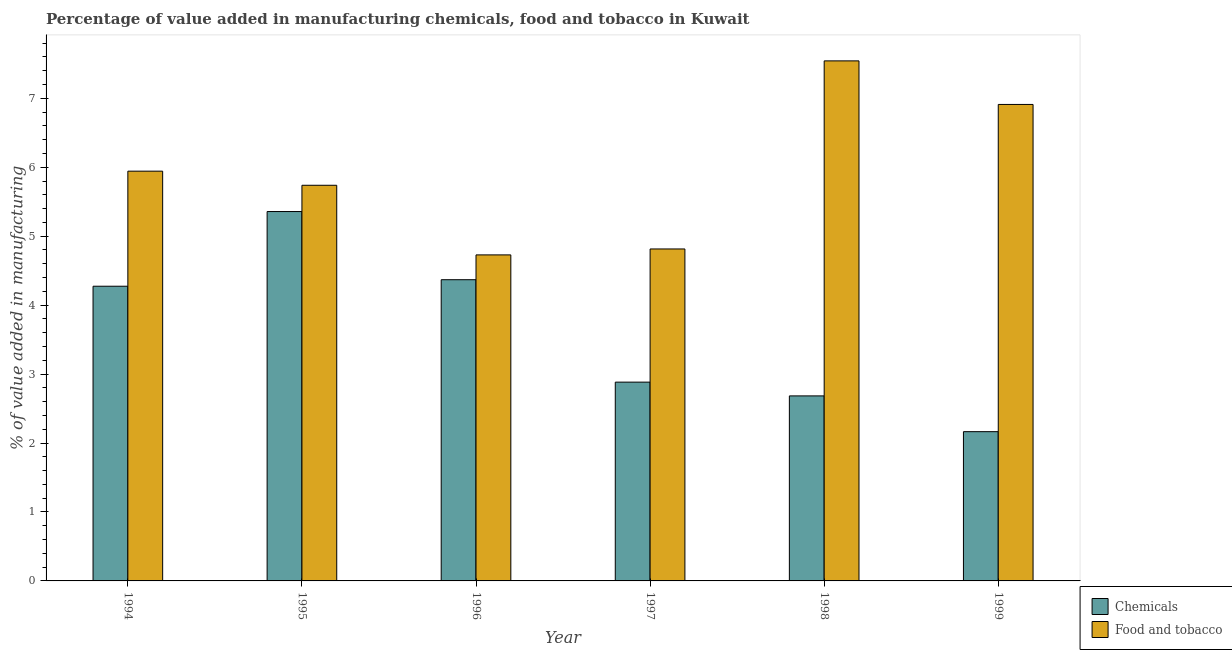How many different coloured bars are there?
Make the answer very short. 2. How many groups of bars are there?
Offer a terse response. 6. Are the number of bars per tick equal to the number of legend labels?
Provide a succinct answer. Yes. Are the number of bars on each tick of the X-axis equal?
Offer a very short reply. Yes. How many bars are there on the 6th tick from the right?
Your answer should be compact. 2. What is the label of the 6th group of bars from the left?
Give a very brief answer. 1999. In how many cases, is the number of bars for a given year not equal to the number of legend labels?
Keep it short and to the point. 0. What is the value added by manufacturing food and tobacco in 1995?
Offer a terse response. 5.74. Across all years, what is the maximum value added by  manufacturing chemicals?
Offer a terse response. 5.36. Across all years, what is the minimum value added by  manufacturing chemicals?
Your response must be concise. 2.16. In which year was the value added by  manufacturing chemicals maximum?
Provide a short and direct response. 1995. What is the total value added by  manufacturing chemicals in the graph?
Provide a short and direct response. 21.73. What is the difference between the value added by manufacturing food and tobacco in 1994 and that in 1995?
Ensure brevity in your answer.  0.2. What is the difference between the value added by manufacturing food and tobacco in 1996 and the value added by  manufacturing chemicals in 1998?
Offer a very short reply. -2.81. What is the average value added by manufacturing food and tobacco per year?
Ensure brevity in your answer.  5.95. In how many years, is the value added by  manufacturing chemicals greater than 4.4 %?
Offer a terse response. 1. What is the ratio of the value added by manufacturing food and tobacco in 1996 to that in 1998?
Provide a short and direct response. 0.63. Is the difference between the value added by  manufacturing chemicals in 1998 and 1999 greater than the difference between the value added by manufacturing food and tobacco in 1998 and 1999?
Your response must be concise. No. What is the difference between the highest and the second highest value added by  manufacturing chemicals?
Offer a very short reply. 0.99. What is the difference between the highest and the lowest value added by manufacturing food and tobacco?
Your answer should be very brief. 2.81. Is the sum of the value added by manufacturing food and tobacco in 1996 and 1998 greater than the maximum value added by  manufacturing chemicals across all years?
Your response must be concise. Yes. What does the 1st bar from the left in 1994 represents?
Your answer should be very brief. Chemicals. What does the 2nd bar from the right in 1995 represents?
Your answer should be very brief. Chemicals. Are all the bars in the graph horizontal?
Offer a terse response. No. How many years are there in the graph?
Ensure brevity in your answer.  6. What is the difference between two consecutive major ticks on the Y-axis?
Make the answer very short. 1. Does the graph contain any zero values?
Offer a terse response. No. Does the graph contain grids?
Provide a succinct answer. No. Where does the legend appear in the graph?
Ensure brevity in your answer.  Bottom right. How are the legend labels stacked?
Provide a short and direct response. Vertical. What is the title of the graph?
Your answer should be very brief. Percentage of value added in manufacturing chemicals, food and tobacco in Kuwait. What is the label or title of the Y-axis?
Your answer should be compact. % of value added in manufacturing. What is the % of value added in manufacturing in Chemicals in 1994?
Keep it short and to the point. 4.27. What is the % of value added in manufacturing of Food and tobacco in 1994?
Your answer should be very brief. 5.94. What is the % of value added in manufacturing in Chemicals in 1995?
Your response must be concise. 5.36. What is the % of value added in manufacturing in Food and tobacco in 1995?
Give a very brief answer. 5.74. What is the % of value added in manufacturing in Chemicals in 1996?
Your response must be concise. 4.37. What is the % of value added in manufacturing in Food and tobacco in 1996?
Offer a terse response. 4.73. What is the % of value added in manufacturing of Chemicals in 1997?
Offer a terse response. 2.88. What is the % of value added in manufacturing of Food and tobacco in 1997?
Ensure brevity in your answer.  4.81. What is the % of value added in manufacturing in Chemicals in 1998?
Your answer should be compact. 2.68. What is the % of value added in manufacturing in Food and tobacco in 1998?
Ensure brevity in your answer.  7.54. What is the % of value added in manufacturing in Chemicals in 1999?
Ensure brevity in your answer.  2.16. What is the % of value added in manufacturing of Food and tobacco in 1999?
Keep it short and to the point. 6.91. Across all years, what is the maximum % of value added in manufacturing in Chemicals?
Provide a short and direct response. 5.36. Across all years, what is the maximum % of value added in manufacturing in Food and tobacco?
Provide a short and direct response. 7.54. Across all years, what is the minimum % of value added in manufacturing of Chemicals?
Offer a very short reply. 2.16. Across all years, what is the minimum % of value added in manufacturing of Food and tobacco?
Your response must be concise. 4.73. What is the total % of value added in manufacturing in Chemicals in the graph?
Offer a terse response. 21.73. What is the total % of value added in manufacturing in Food and tobacco in the graph?
Offer a terse response. 35.68. What is the difference between the % of value added in manufacturing in Chemicals in 1994 and that in 1995?
Your answer should be very brief. -1.08. What is the difference between the % of value added in manufacturing of Food and tobacco in 1994 and that in 1995?
Keep it short and to the point. 0.2. What is the difference between the % of value added in manufacturing in Chemicals in 1994 and that in 1996?
Ensure brevity in your answer.  -0.09. What is the difference between the % of value added in manufacturing in Food and tobacco in 1994 and that in 1996?
Provide a short and direct response. 1.21. What is the difference between the % of value added in manufacturing in Chemicals in 1994 and that in 1997?
Ensure brevity in your answer.  1.39. What is the difference between the % of value added in manufacturing in Food and tobacco in 1994 and that in 1997?
Ensure brevity in your answer.  1.13. What is the difference between the % of value added in manufacturing of Chemicals in 1994 and that in 1998?
Ensure brevity in your answer.  1.59. What is the difference between the % of value added in manufacturing of Food and tobacco in 1994 and that in 1998?
Your answer should be very brief. -1.6. What is the difference between the % of value added in manufacturing of Chemicals in 1994 and that in 1999?
Make the answer very short. 2.11. What is the difference between the % of value added in manufacturing of Food and tobacco in 1994 and that in 1999?
Give a very brief answer. -0.97. What is the difference between the % of value added in manufacturing of Chemicals in 1995 and that in 1996?
Your answer should be compact. 0.99. What is the difference between the % of value added in manufacturing of Food and tobacco in 1995 and that in 1996?
Your response must be concise. 1.01. What is the difference between the % of value added in manufacturing of Chemicals in 1995 and that in 1997?
Provide a short and direct response. 2.47. What is the difference between the % of value added in manufacturing of Food and tobacco in 1995 and that in 1997?
Your response must be concise. 0.92. What is the difference between the % of value added in manufacturing in Chemicals in 1995 and that in 1998?
Provide a succinct answer. 2.67. What is the difference between the % of value added in manufacturing of Food and tobacco in 1995 and that in 1998?
Your answer should be compact. -1.8. What is the difference between the % of value added in manufacturing of Chemicals in 1995 and that in 1999?
Offer a terse response. 3.19. What is the difference between the % of value added in manufacturing in Food and tobacco in 1995 and that in 1999?
Ensure brevity in your answer.  -1.17. What is the difference between the % of value added in manufacturing of Chemicals in 1996 and that in 1997?
Make the answer very short. 1.49. What is the difference between the % of value added in manufacturing of Food and tobacco in 1996 and that in 1997?
Offer a very short reply. -0.09. What is the difference between the % of value added in manufacturing in Chemicals in 1996 and that in 1998?
Your answer should be compact. 1.69. What is the difference between the % of value added in manufacturing in Food and tobacco in 1996 and that in 1998?
Your answer should be compact. -2.81. What is the difference between the % of value added in manufacturing in Chemicals in 1996 and that in 1999?
Your response must be concise. 2.2. What is the difference between the % of value added in manufacturing in Food and tobacco in 1996 and that in 1999?
Your response must be concise. -2.18. What is the difference between the % of value added in manufacturing of Chemicals in 1997 and that in 1998?
Offer a very short reply. 0.2. What is the difference between the % of value added in manufacturing of Food and tobacco in 1997 and that in 1998?
Provide a short and direct response. -2.73. What is the difference between the % of value added in manufacturing of Chemicals in 1997 and that in 1999?
Provide a short and direct response. 0.72. What is the difference between the % of value added in manufacturing of Food and tobacco in 1997 and that in 1999?
Make the answer very short. -2.1. What is the difference between the % of value added in manufacturing in Chemicals in 1998 and that in 1999?
Offer a very short reply. 0.52. What is the difference between the % of value added in manufacturing of Food and tobacco in 1998 and that in 1999?
Keep it short and to the point. 0.63. What is the difference between the % of value added in manufacturing of Chemicals in 1994 and the % of value added in manufacturing of Food and tobacco in 1995?
Your answer should be very brief. -1.46. What is the difference between the % of value added in manufacturing of Chemicals in 1994 and the % of value added in manufacturing of Food and tobacco in 1996?
Provide a short and direct response. -0.45. What is the difference between the % of value added in manufacturing in Chemicals in 1994 and the % of value added in manufacturing in Food and tobacco in 1997?
Your answer should be very brief. -0.54. What is the difference between the % of value added in manufacturing in Chemicals in 1994 and the % of value added in manufacturing in Food and tobacco in 1998?
Give a very brief answer. -3.27. What is the difference between the % of value added in manufacturing of Chemicals in 1994 and the % of value added in manufacturing of Food and tobacco in 1999?
Your answer should be compact. -2.64. What is the difference between the % of value added in manufacturing of Chemicals in 1995 and the % of value added in manufacturing of Food and tobacco in 1996?
Keep it short and to the point. 0.63. What is the difference between the % of value added in manufacturing in Chemicals in 1995 and the % of value added in manufacturing in Food and tobacco in 1997?
Make the answer very short. 0.54. What is the difference between the % of value added in manufacturing in Chemicals in 1995 and the % of value added in manufacturing in Food and tobacco in 1998?
Give a very brief answer. -2.19. What is the difference between the % of value added in manufacturing in Chemicals in 1995 and the % of value added in manufacturing in Food and tobacco in 1999?
Your answer should be very brief. -1.55. What is the difference between the % of value added in manufacturing in Chemicals in 1996 and the % of value added in manufacturing in Food and tobacco in 1997?
Give a very brief answer. -0.45. What is the difference between the % of value added in manufacturing in Chemicals in 1996 and the % of value added in manufacturing in Food and tobacco in 1998?
Make the answer very short. -3.17. What is the difference between the % of value added in manufacturing in Chemicals in 1996 and the % of value added in manufacturing in Food and tobacco in 1999?
Your answer should be compact. -2.54. What is the difference between the % of value added in manufacturing of Chemicals in 1997 and the % of value added in manufacturing of Food and tobacco in 1998?
Your answer should be compact. -4.66. What is the difference between the % of value added in manufacturing in Chemicals in 1997 and the % of value added in manufacturing in Food and tobacco in 1999?
Keep it short and to the point. -4.03. What is the difference between the % of value added in manufacturing of Chemicals in 1998 and the % of value added in manufacturing of Food and tobacco in 1999?
Give a very brief answer. -4.23. What is the average % of value added in manufacturing in Chemicals per year?
Offer a terse response. 3.62. What is the average % of value added in manufacturing of Food and tobacco per year?
Your answer should be very brief. 5.95. In the year 1994, what is the difference between the % of value added in manufacturing in Chemicals and % of value added in manufacturing in Food and tobacco?
Ensure brevity in your answer.  -1.67. In the year 1995, what is the difference between the % of value added in manufacturing of Chemicals and % of value added in manufacturing of Food and tobacco?
Your answer should be compact. -0.38. In the year 1996, what is the difference between the % of value added in manufacturing of Chemicals and % of value added in manufacturing of Food and tobacco?
Offer a very short reply. -0.36. In the year 1997, what is the difference between the % of value added in manufacturing in Chemicals and % of value added in manufacturing in Food and tobacco?
Give a very brief answer. -1.93. In the year 1998, what is the difference between the % of value added in manufacturing in Chemicals and % of value added in manufacturing in Food and tobacco?
Your answer should be compact. -4.86. In the year 1999, what is the difference between the % of value added in manufacturing of Chemicals and % of value added in manufacturing of Food and tobacco?
Provide a succinct answer. -4.75. What is the ratio of the % of value added in manufacturing in Chemicals in 1994 to that in 1995?
Offer a terse response. 0.8. What is the ratio of the % of value added in manufacturing in Food and tobacco in 1994 to that in 1995?
Keep it short and to the point. 1.04. What is the ratio of the % of value added in manufacturing in Chemicals in 1994 to that in 1996?
Provide a short and direct response. 0.98. What is the ratio of the % of value added in manufacturing of Food and tobacco in 1994 to that in 1996?
Provide a short and direct response. 1.26. What is the ratio of the % of value added in manufacturing of Chemicals in 1994 to that in 1997?
Keep it short and to the point. 1.48. What is the ratio of the % of value added in manufacturing in Food and tobacco in 1994 to that in 1997?
Ensure brevity in your answer.  1.23. What is the ratio of the % of value added in manufacturing of Chemicals in 1994 to that in 1998?
Your response must be concise. 1.59. What is the ratio of the % of value added in manufacturing of Food and tobacco in 1994 to that in 1998?
Ensure brevity in your answer.  0.79. What is the ratio of the % of value added in manufacturing in Chemicals in 1994 to that in 1999?
Provide a succinct answer. 1.97. What is the ratio of the % of value added in manufacturing of Food and tobacco in 1994 to that in 1999?
Your answer should be very brief. 0.86. What is the ratio of the % of value added in manufacturing of Chemicals in 1995 to that in 1996?
Offer a very short reply. 1.23. What is the ratio of the % of value added in manufacturing in Food and tobacco in 1995 to that in 1996?
Offer a terse response. 1.21. What is the ratio of the % of value added in manufacturing of Chemicals in 1995 to that in 1997?
Offer a very short reply. 1.86. What is the ratio of the % of value added in manufacturing of Food and tobacco in 1995 to that in 1997?
Provide a succinct answer. 1.19. What is the ratio of the % of value added in manufacturing in Chemicals in 1995 to that in 1998?
Your answer should be compact. 2. What is the ratio of the % of value added in manufacturing in Food and tobacco in 1995 to that in 1998?
Provide a short and direct response. 0.76. What is the ratio of the % of value added in manufacturing of Chemicals in 1995 to that in 1999?
Ensure brevity in your answer.  2.47. What is the ratio of the % of value added in manufacturing of Food and tobacco in 1995 to that in 1999?
Keep it short and to the point. 0.83. What is the ratio of the % of value added in manufacturing in Chemicals in 1996 to that in 1997?
Your answer should be compact. 1.52. What is the ratio of the % of value added in manufacturing in Food and tobacco in 1996 to that in 1997?
Offer a terse response. 0.98. What is the ratio of the % of value added in manufacturing of Chemicals in 1996 to that in 1998?
Ensure brevity in your answer.  1.63. What is the ratio of the % of value added in manufacturing in Food and tobacco in 1996 to that in 1998?
Give a very brief answer. 0.63. What is the ratio of the % of value added in manufacturing of Chemicals in 1996 to that in 1999?
Your answer should be very brief. 2.02. What is the ratio of the % of value added in manufacturing in Food and tobacco in 1996 to that in 1999?
Offer a very short reply. 0.68. What is the ratio of the % of value added in manufacturing in Chemicals in 1997 to that in 1998?
Offer a terse response. 1.07. What is the ratio of the % of value added in manufacturing in Food and tobacco in 1997 to that in 1998?
Give a very brief answer. 0.64. What is the ratio of the % of value added in manufacturing of Chemicals in 1997 to that in 1999?
Give a very brief answer. 1.33. What is the ratio of the % of value added in manufacturing of Food and tobacco in 1997 to that in 1999?
Keep it short and to the point. 0.7. What is the ratio of the % of value added in manufacturing in Chemicals in 1998 to that in 1999?
Keep it short and to the point. 1.24. What is the ratio of the % of value added in manufacturing of Food and tobacco in 1998 to that in 1999?
Give a very brief answer. 1.09. What is the difference between the highest and the second highest % of value added in manufacturing of Chemicals?
Make the answer very short. 0.99. What is the difference between the highest and the second highest % of value added in manufacturing of Food and tobacco?
Your answer should be very brief. 0.63. What is the difference between the highest and the lowest % of value added in manufacturing of Chemicals?
Your response must be concise. 3.19. What is the difference between the highest and the lowest % of value added in manufacturing in Food and tobacco?
Offer a very short reply. 2.81. 